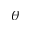Convert formula to latex. <formula><loc_0><loc_0><loc_500><loc_500>\theta</formula> 